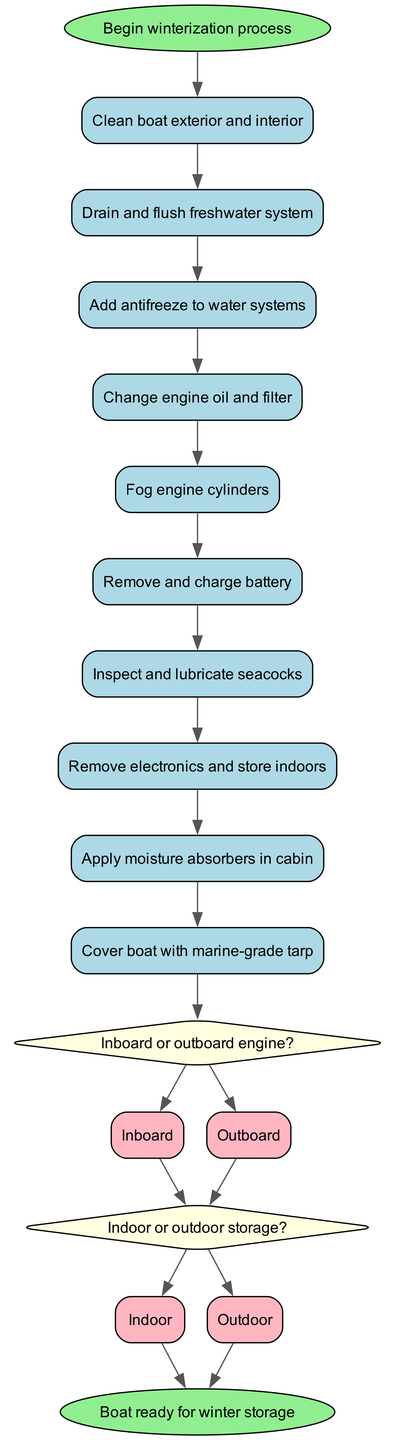What is the first activity in the winterization process? The diagram starts with the "Begin winterization process" and indicates that the first activity directly connected to it is "Clean boat exterior and interior."
Answer: Clean boat exterior and interior How many activities are listed in the diagram? There are a total of 10 activities shown in the diagram, which includes the cleaning, system checks, and protective measures.
Answer: 10 What decision is made after the last activity? The last activity "Cover boat with marine-grade tarp" is followed by the decision "Inboard or outboard engine?" which is a branching point for the winterization process.
Answer: Inboard or outboard engine? Which option is connected to the end node? The options "Indoor" and "Outdoor" from the second decision go to the end node "Boat ready for winter storage," indicating different storage methods.
Answer: Indoor, Outdoor What is the sequence of activities before any decisions are made? The sequence of activities before decisions includes: Clean boat exterior and interior, Drain and flush freshwater system, Add antifreeze to water systems, Change engine oil and filter, Fog engine cylinders, Remove and charge battery, and Inspect and lubricate seacocks.
Answer: 7 activities How does the decision of engine type influence the next steps? The decision of engine type (Inboard or Outboard) leads to the next decision regarding storage type (Indoor or Outdoor), affecting the final preparation for winter storage. Thus, it sets the path depending on what type of engine one has.
Answer: Affects storage decision What color represents the decision nodes in the diagram? The decision nodes in the diagram are represented by a light yellow color, distinguishing them visually from activities and other elements.
Answer: Light yellow How many options are available for the engine decision? There are 2 options available for the engine decision: "Inboard" and "Outboard," allowing for differentiation in winterizing processes based on engine type.
Answer: 2 options What happens after selecting "Outdoor" in the storage decision? After selecting "Outdoor" in the storage decision, the flow also leads directly to the end node "Boat ready for winter storage," indicating that the preparation is complete for both storage types.
Answer: Ends at "Boat ready for winter storage" 